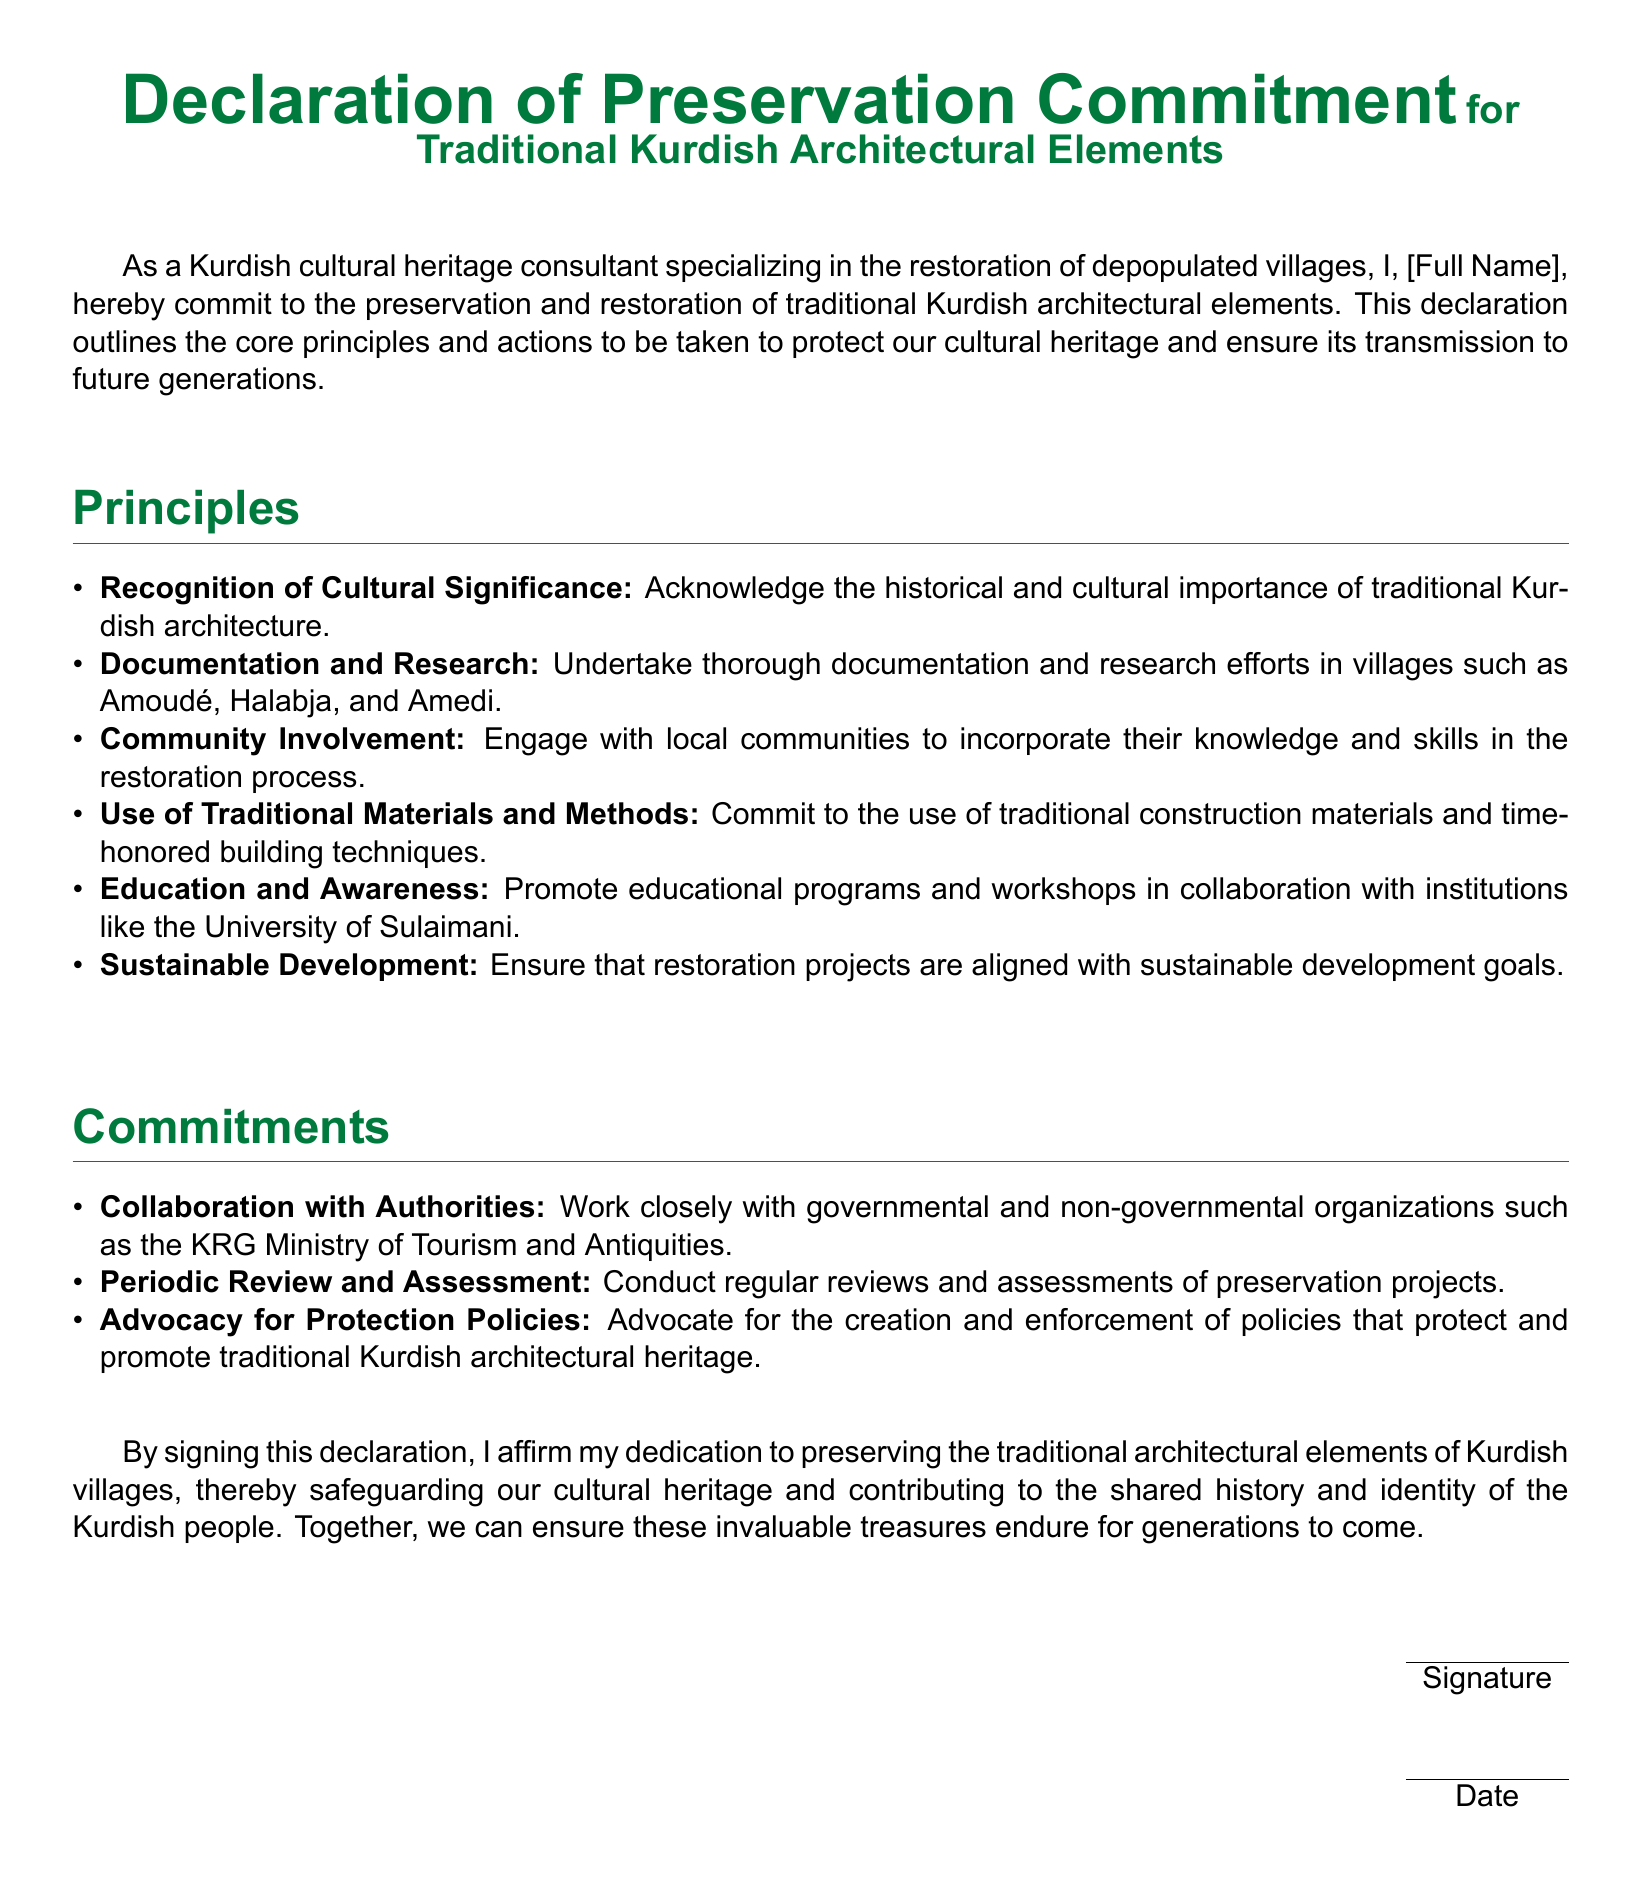What is the title of the document? The title is highlighted in the center of the document and signifies the focus on preservation of cultural elements.
Answer: Declaration of Preservation Commitment for Traditional Kurdish Architectural Elements Who is the author of the declaration? The author’s identity is indicated by the placeholder for their name in the document.
Answer: [Full Name] Which villages are mentioned for documentation and research? The document lists specific villages under the principles section specifically for research efforts.
Answer: Amoudé, Halabja, Amedi What is one of the core principles of the declaration? The document outlines several core principles aimed at preserving traditional architecture.
Answer: Recognition of Cultural Significance What type of materials and methods does the declaration commit to using? The text specifies a commitment to certain types of construction approaches in preservation efforts.
Answer: Traditional construction materials and time-honored building techniques Which organization is mentioned for collaboration in the commitments section? The document refers to a specific organization that relates to tourism and antiquities preservation.
Answer: KRG Ministry of Tourism and Antiquities What action is to be taken regarding preservation projects? The declaration states an ongoing process concerning the evaluation of restoration efforts.
Answer: Periodic Review and Assessment What is the main goal of the declaration? The document expresses the overarching aim of the commitment towards cultural preservation.
Answer: Safeguarding cultural heritage 